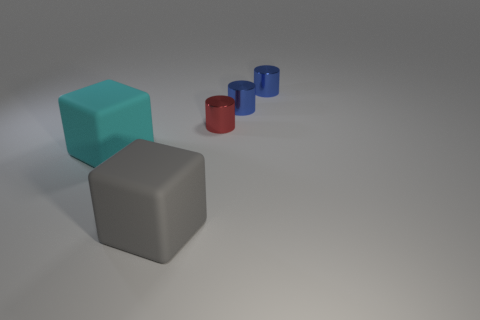What is the size of the cyan rubber thing that is the same shape as the big gray rubber object?
Your answer should be compact. Large. Are there any other things that are the same size as the gray thing?
Make the answer very short. Yes. Do the large cyan matte thing and the gray matte thing have the same shape?
Provide a short and direct response. Yes. What size is the block that is on the left side of the matte cube that is in front of the cyan rubber block?
Offer a terse response. Large. What is the color of the other matte thing that is the same shape as the gray object?
Your answer should be compact. Cyan. How big is the gray rubber object?
Give a very brief answer. Large. Do the gray object and the red thing have the same size?
Make the answer very short. No. The object that is to the left of the small red shiny cylinder and behind the big gray rubber block is what color?
Make the answer very short. Cyan. What number of other large things have the same material as the large cyan object?
Offer a very short reply. 1. How many red metallic objects are there?
Provide a short and direct response. 1. 